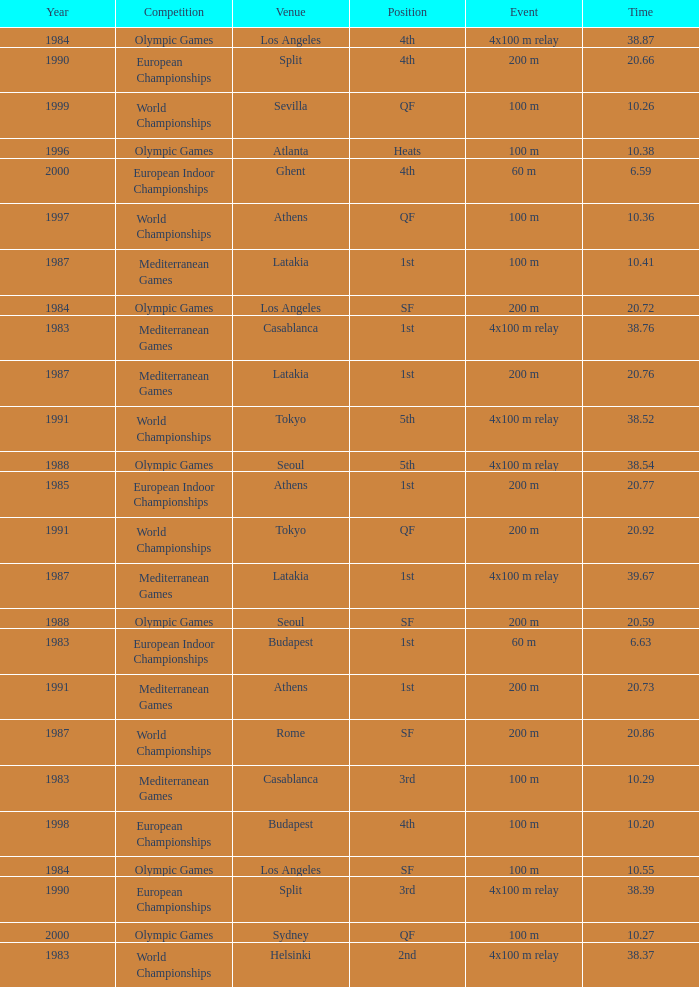Parse the full table. {'header': ['Year', 'Competition', 'Venue', 'Position', 'Event', 'Time'], 'rows': [['1984', 'Olympic Games', 'Los Angeles', '4th', '4x100 m relay', '38.87'], ['1990', 'European Championships', 'Split', '4th', '200 m', '20.66'], ['1999', 'World Championships', 'Sevilla', 'QF', '100 m', '10.26'], ['1996', 'Olympic Games', 'Atlanta', 'Heats', '100 m', '10.38'], ['2000', 'European Indoor Championships', 'Ghent', '4th', '60 m', '6.59'], ['1997', 'World Championships', 'Athens', 'QF', '100 m', '10.36'], ['1987', 'Mediterranean Games', 'Latakia', '1st', '100 m', '10.41'], ['1984', 'Olympic Games', 'Los Angeles', 'SF', '200 m', '20.72'], ['1983', 'Mediterranean Games', 'Casablanca', '1st', '4x100 m relay', '38.76'], ['1987', 'Mediterranean Games', 'Latakia', '1st', '200 m', '20.76'], ['1991', 'World Championships', 'Tokyo', '5th', '4x100 m relay', '38.52'], ['1988', 'Olympic Games', 'Seoul', '5th', '4x100 m relay', '38.54'], ['1985', 'European Indoor Championships', 'Athens', '1st', '200 m', '20.77'], ['1991', 'World Championships', 'Tokyo', 'QF', '200 m', '20.92'], ['1987', 'Mediterranean Games', 'Latakia', '1st', '4x100 m relay', '39.67'], ['1988', 'Olympic Games', 'Seoul', 'SF', '200 m', '20.59'], ['1983', 'European Indoor Championships', 'Budapest', '1st', '60 m', '6.63'], ['1991', 'Mediterranean Games', 'Athens', '1st', '200 m', '20.73'], ['1987', 'World Championships', 'Rome', 'SF', '200 m', '20.86'], ['1983', 'Mediterranean Games', 'Casablanca', '3rd', '100 m', '10.29'], ['1998', 'European Championships', 'Budapest', '4th', '100 m', '10.20'], ['1984', 'Olympic Games', 'Los Angeles', 'SF', '100 m', '10.55'], ['1990', 'European Championships', 'Split', '3rd', '4x100 m relay', '38.39'], ['2000', 'Olympic Games', 'Sydney', 'QF', '100 m', '10.27'], ['1983', 'World Championships', 'Helsinki', '2nd', '4x100 m relay', '38.37']]} What is the greatest Time with a Year of 1991, and Event of 4x100 m relay? 38.52. 